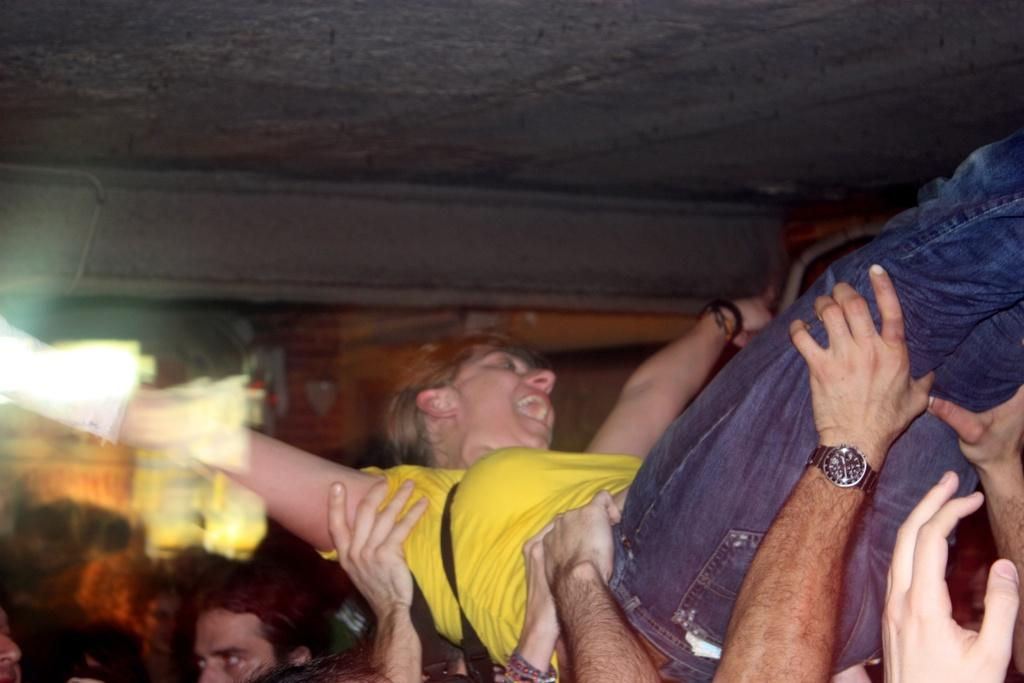What is the primary subject of the image? There is a person in the image. How is the person being supported in the image? The person is being held by a group of people. What color is the top that the person is wearing? The person is wearing a yellow top. What type of pants is the person wearing? The person is wearing blue jeans. What type of vegetable is being used to hold up the person in the image? There is no vegetable present in the image; the person is being held up by a group of people. 